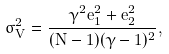Convert formula to latex. <formula><loc_0><loc_0><loc_500><loc_500>\sigma _ { V } ^ { 2 } = \frac { \gamma ^ { 2 } e _ { 1 } ^ { 2 } + e _ { 2 } ^ { 2 } } { ( N - 1 ) ( \gamma - 1 ) ^ { 2 } } ,</formula> 